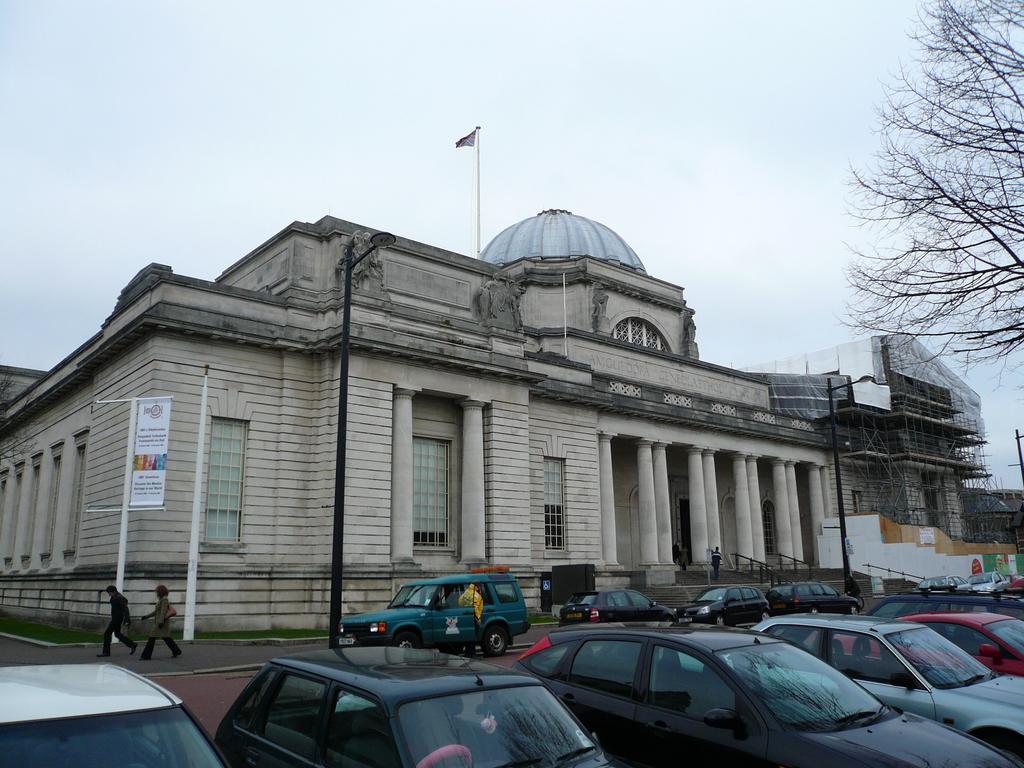Please provide a concise description of this image. In this image we can see buildings, flag, flag post, advertisement, street poles, street lights, persons on the road, ground, sky and motor vehicles parked on the road. 